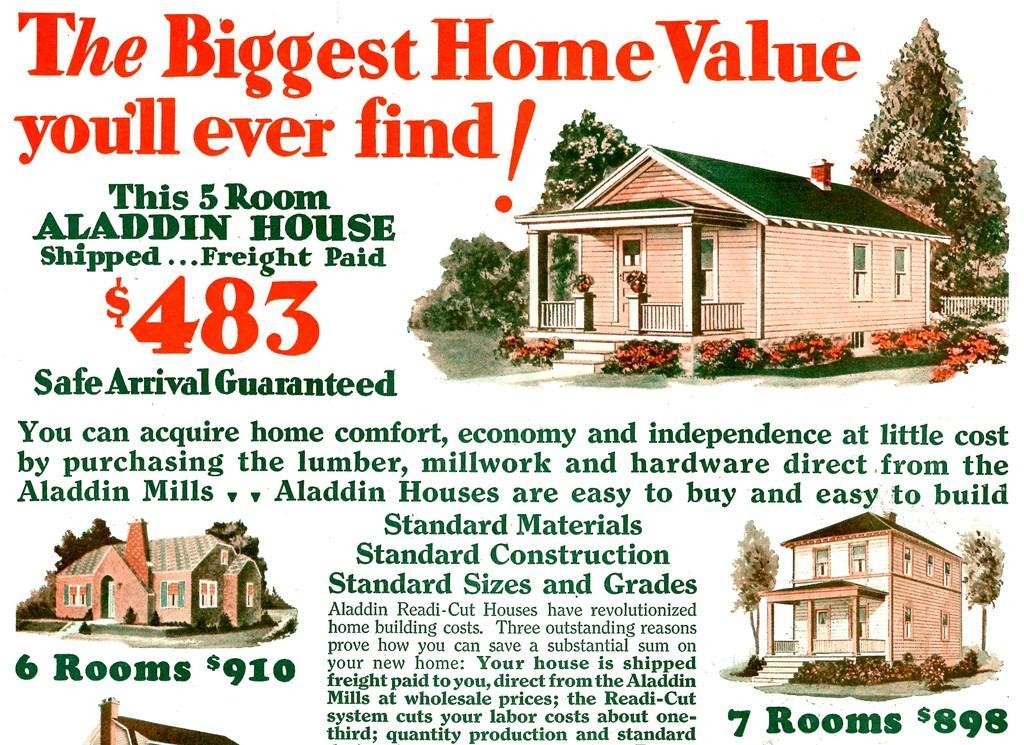Describe this image in one or two sentences. In the picture I can see houses, trees and some text, And this image is an article. 